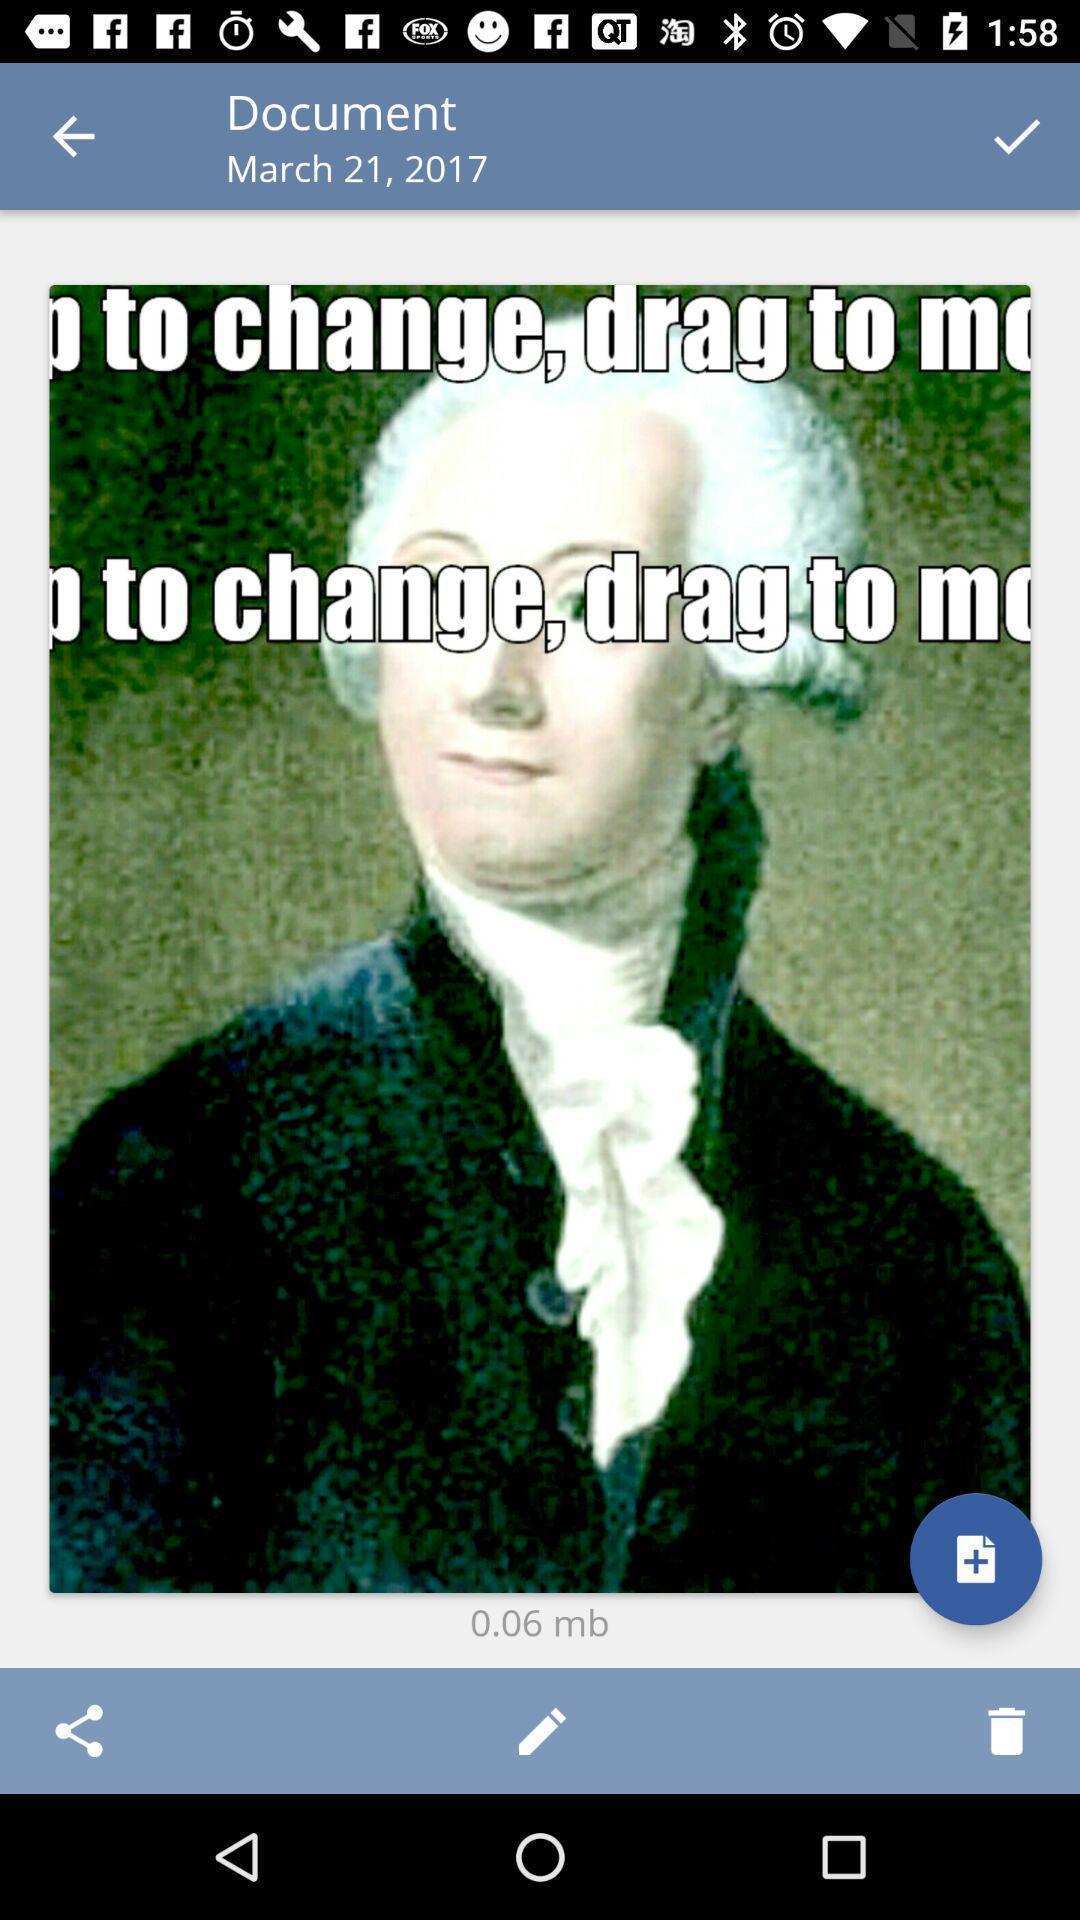Tell me about the visual elements in this screen capture. Screen shows document with an image. 